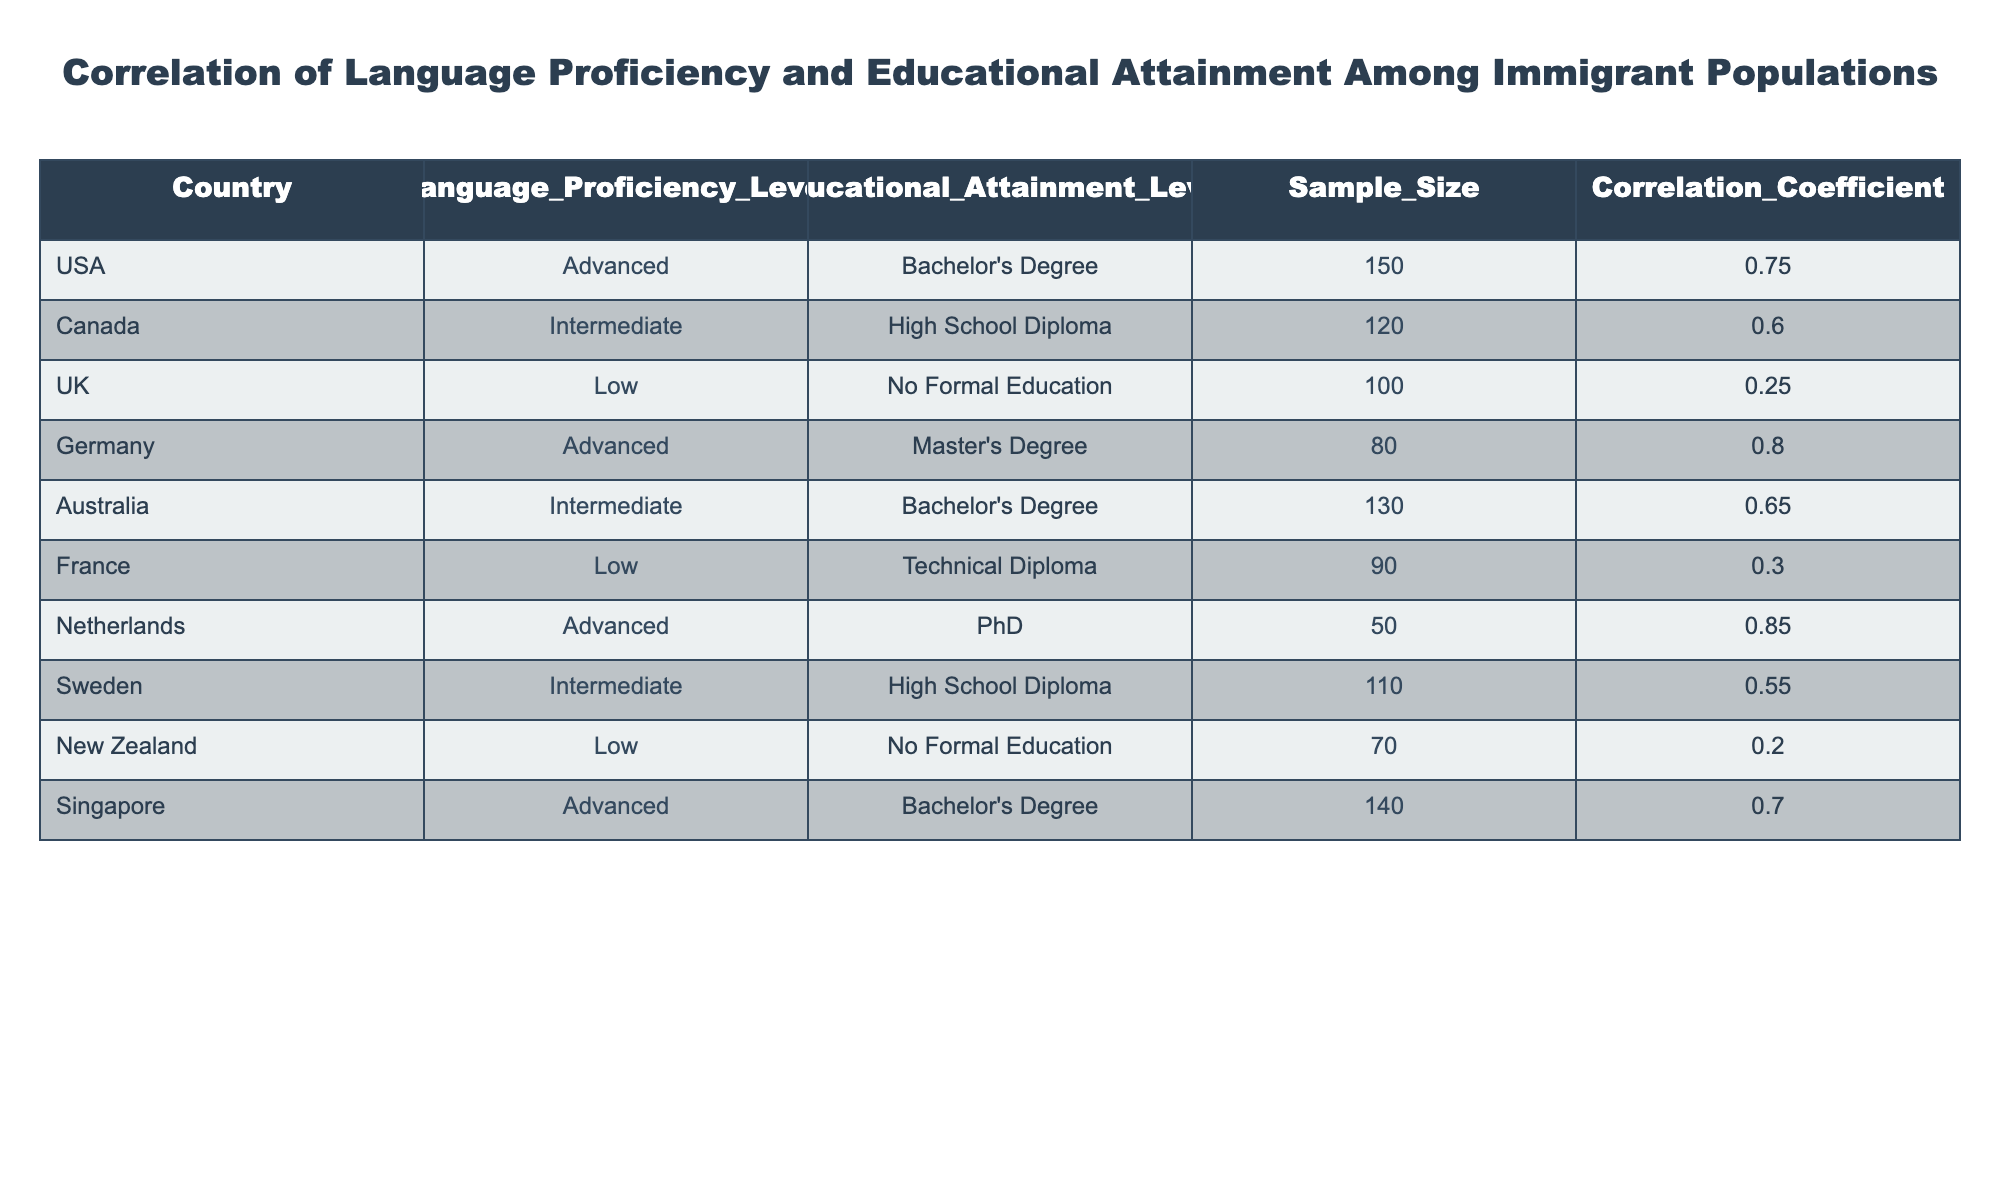What is the correlation coefficient for Germany? In the table, find Germany in the 'Country' column. The corresponding 'Correlation Coefficient' value is listed in the same row. For Germany, it is 0.80.
Answer: 0.80 Which country has the lowest correlation coefficient? To find the lowest correlation coefficient, look through the 'Correlation Coefficient' column for the smallest value. The lowest value in the table is 0.20, which corresponds to New Zealand.
Answer: New Zealand What is the average correlation coefficient for all countries listed? To calculate the average, add all the correlation coefficients together: 0.75 + 0.60 + 0.25 + 0.80 + 0.65 + 0.30 + 0.85 + 0.55 + 0.20 + 0.70 = 5.65. Then, divide by the number of countries (10): 5.65 / 10 = 0.565.
Answer: 0.565 Is there any country with a correlation coefficient above 0.75? By scanning the 'Correlation Coefficient' column, we can see that the values greater than 0.75 are for the USA (0.75), Germany (0.80), and the Netherlands (0.85). Thus, the answer is yes.
Answer: Yes What is the difference in correlation coefficients between the USA and the UK? Look at the 'Correlation Coefficient' for both countries: USA has 0.75 and UK has 0.25. To find the difference, subtract the UK value from the USA value: 0.75 - 0.25 = 0.50.
Answer: 0.50 Which educational attainment level corresponds to the highest correlation coefficient? The table shows that the highest correlation coefficient (0.85) is associated with the Netherlands, which corresponds to a PhD educational attainment level.
Answer: PhD How many countries have an intermediate language proficiency level? Count the instances of 'Intermediate' in the 'Language Proficiency Level' column. The countries with 'Intermediate' proficiency are Canada, Australia, and Sweden, totaling three countries.
Answer: 3 Is it true that all countries with advanced language proficiency have at least a Bachelor's degree? Check the 'Country', 'Language Proficiency Level', and 'Educational Attainment Level' columns to see which countries have advanced proficiency. The countries USA, Germany, Netherlands, and Singapore all have educational attainment levels of either Bachelor's, Master's, or PhD, confirming the statement is true.
Answer: Yes 